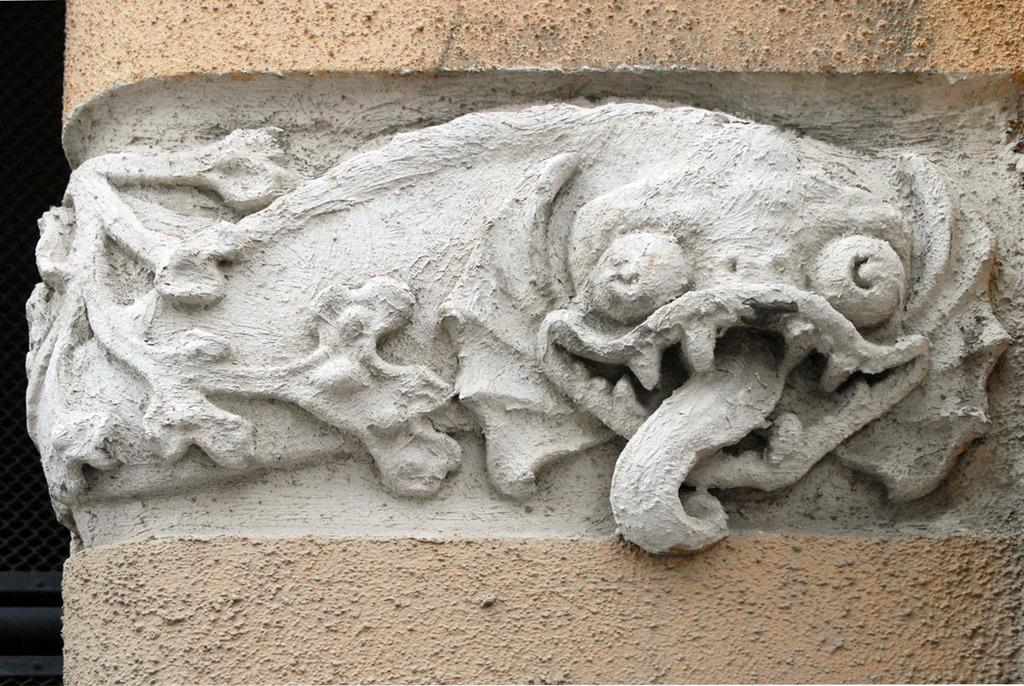What is the main subject in the image? There is a carved stone in the image. What type of jelly can be seen in the image? There is no jelly present in the image; it features a carved stone. What type of art is displayed in the lunchroom in the image? There is no lunchroom or art present in the image; it only features a carved stone. 